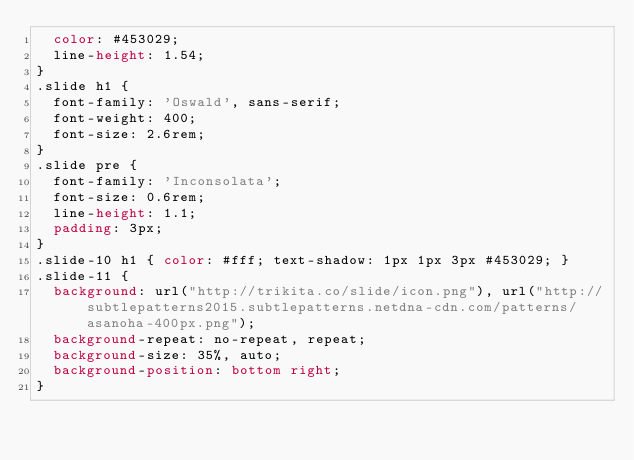<code> <loc_0><loc_0><loc_500><loc_500><_CSS_>  color: #453029;
  line-height: 1.54;
}
.slide h1 {
  font-family: 'Oswald', sans-serif;
  font-weight: 400;
  font-size: 2.6rem;
}
.slide pre {
  font-family: 'Inconsolata';
  font-size: 0.6rem;
  line-height: 1.1;
  padding: 3px;
}
.slide-10 h1 { color: #fff; text-shadow: 1px 1px 3px #453029; }
.slide-11 {
  background: url("http://trikita.co/slide/icon.png"), url("http://subtlepatterns2015.subtlepatterns.netdna-cdn.com/patterns/asanoha-400px.png");
  background-repeat: no-repeat, repeat;
  background-size: 35%, auto;
  background-position: bottom right;
}</code> 